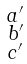Convert formula to latex. <formula><loc_0><loc_0><loc_500><loc_500>\begin{smallmatrix} a ^ { \prime } \\ b ^ { \prime } \\ c ^ { \prime } \\ \end{smallmatrix}</formula> 